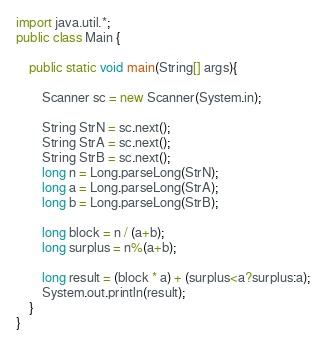Convert code to text. <code><loc_0><loc_0><loc_500><loc_500><_Java_>import java.util.*;
public class Main {
	
	public static void main(String[] args){
		
		Scanner sc = new Scanner(System.in);
		
		String StrN = sc.next();
		String StrA = sc.next();
		String StrB = sc.next();
		long n = Long.parseLong(StrN);
		long a = Long.parseLong(StrA);
		long b = Long.parseLong(StrB);

		long block = n / (a+b);
		long surplus = n%(a+b);
		
		long result = (block * a) + (surplus<a?surplus:a);
		System.out.println(result);
	}
}</code> 